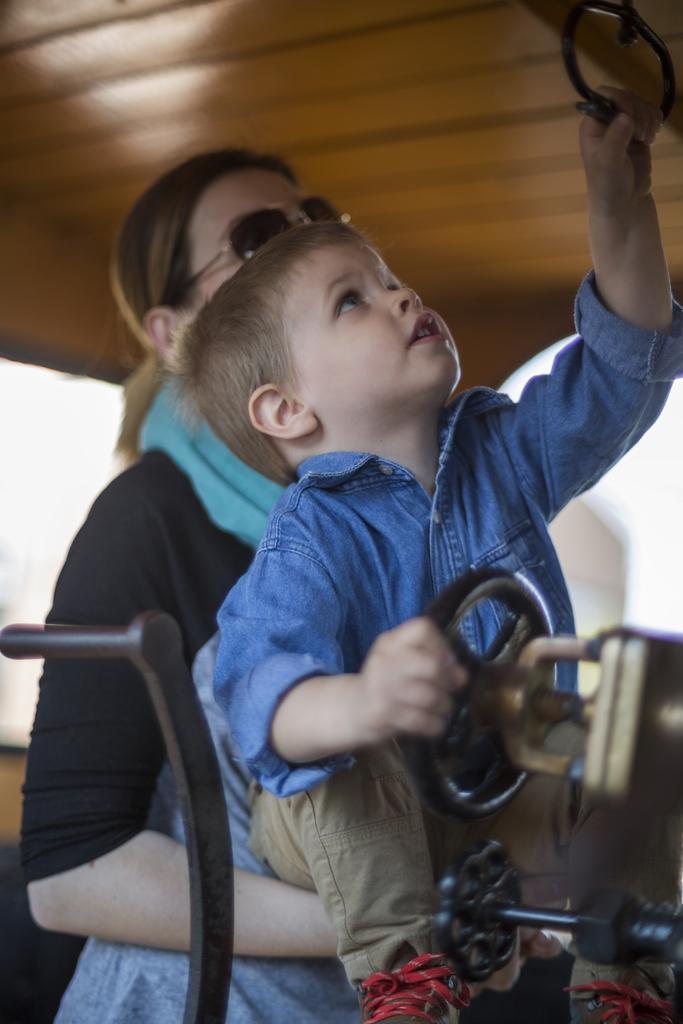Please provide a concise description of this image. In this picture I can see there is a woman and a kid, the kid is holding an object and the woman is wearing a scarf and goggles. 